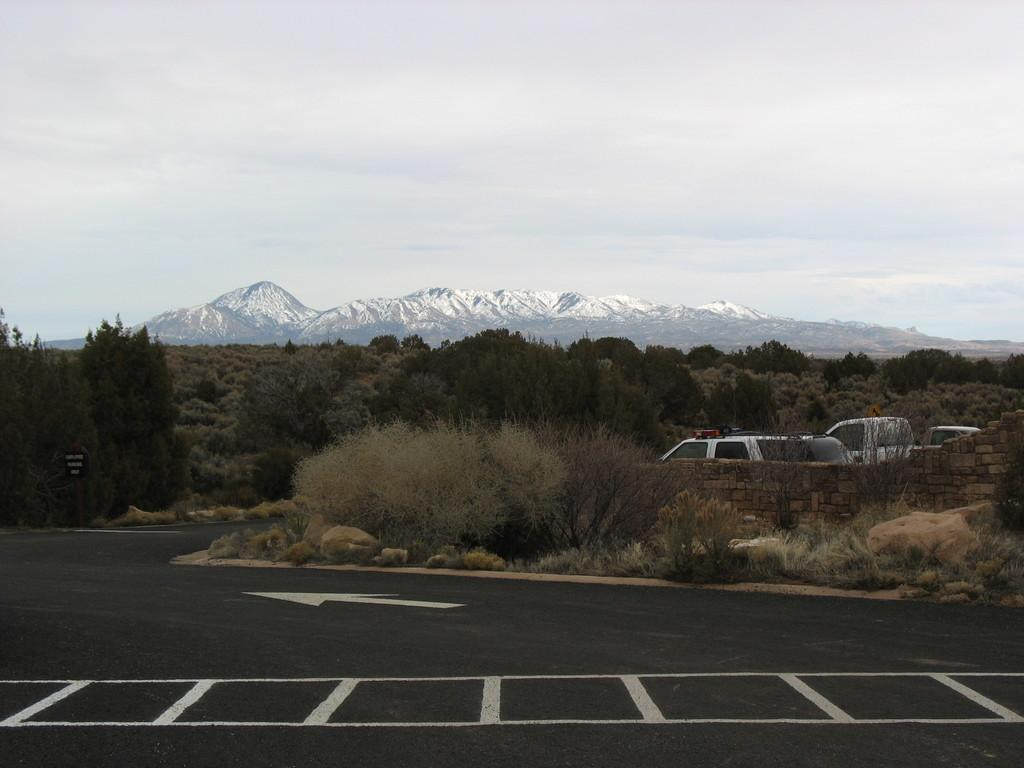What is the main feature of the image? There is a road in the image. Where are the vehicles located in the image? The vehicles are in the right corner of the image. What can be seen in the background of the image? There are trees and mountains in the background of the image. Can you see a garden in the image? There is no garden present in the image. What is the good-bye attempt like in the image? There is no good-bye attempt depicted in the image. 